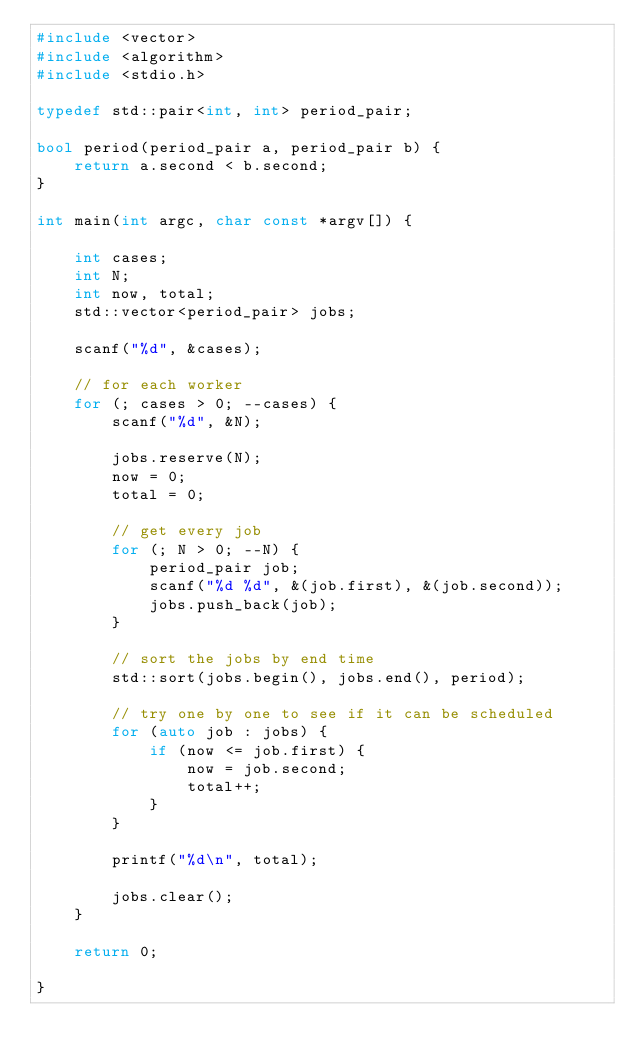Convert code to text. <code><loc_0><loc_0><loc_500><loc_500><_C++_>#include <vector>
#include <algorithm>
#include <stdio.h>

typedef std::pair<int, int> period_pair;

bool period(period_pair a, period_pair b) {
    return a.second < b.second;
}

int main(int argc, char const *argv[]) {

    int cases;
    int N;
    int now, total;
    std::vector<period_pair> jobs;

    scanf("%d", &cases);

    // for each worker
    for (; cases > 0; --cases) {
        scanf("%d", &N);

        jobs.reserve(N);
        now = 0;
        total = 0;

        // get every job
        for (; N > 0; --N) {
            period_pair job;
            scanf("%d %d", &(job.first), &(job.second));
            jobs.push_back(job);
        }

        // sort the jobs by end time
        std::sort(jobs.begin(), jobs.end(), period);

        // try one by one to see if it can be scheduled
        for (auto job : jobs) {
            if (now <= job.first) {
                now = job.second;
                total++;
            }
        }

        printf("%d\n", total);

        jobs.clear();
    }

    return 0;

}
</code> 